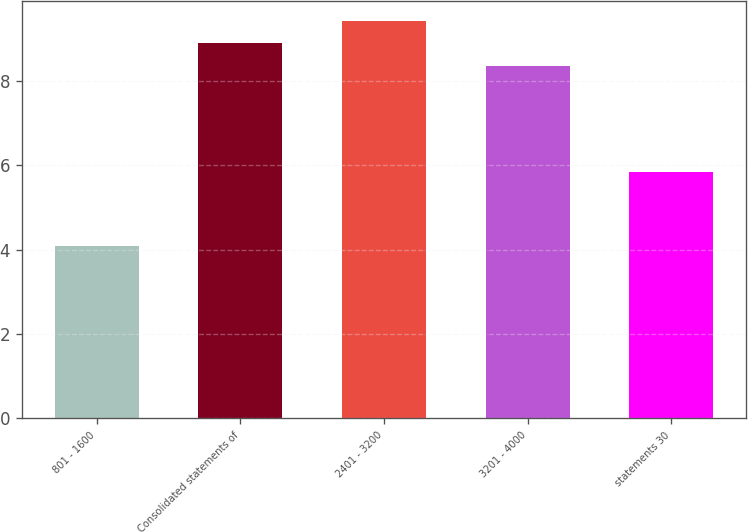Convert chart to OTSL. <chart><loc_0><loc_0><loc_500><loc_500><bar_chart><fcel>801 - 1600<fcel>Consolidated statements of<fcel>2401 - 3200<fcel>3201 - 4000<fcel>statements 30<nl><fcel>4.1<fcel>8.9<fcel>9.43<fcel>8.37<fcel>5.85<nl></chart> 